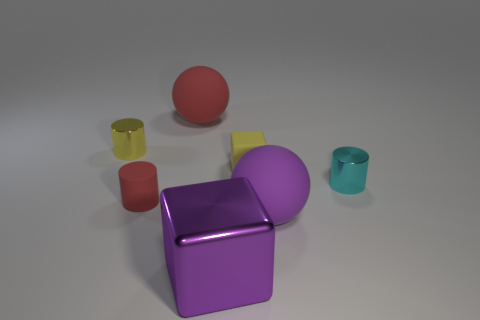Add 3 tiny shiny cylinders. How many objects exist? 10 Subtract all cylinders. How many objects are left? 4 Subtract all gray cylinders. Subtract all green cubes. How many cylinders are left? 3 Add 5 big matte things. How many big matte things exist? 7 Subtract 0 green cubes. How many objects are left? 7 Subtract all small cubes. Subtract all small cubes. How many objects are left? 5 Add 2 blocks. How many blocks are left? 4 